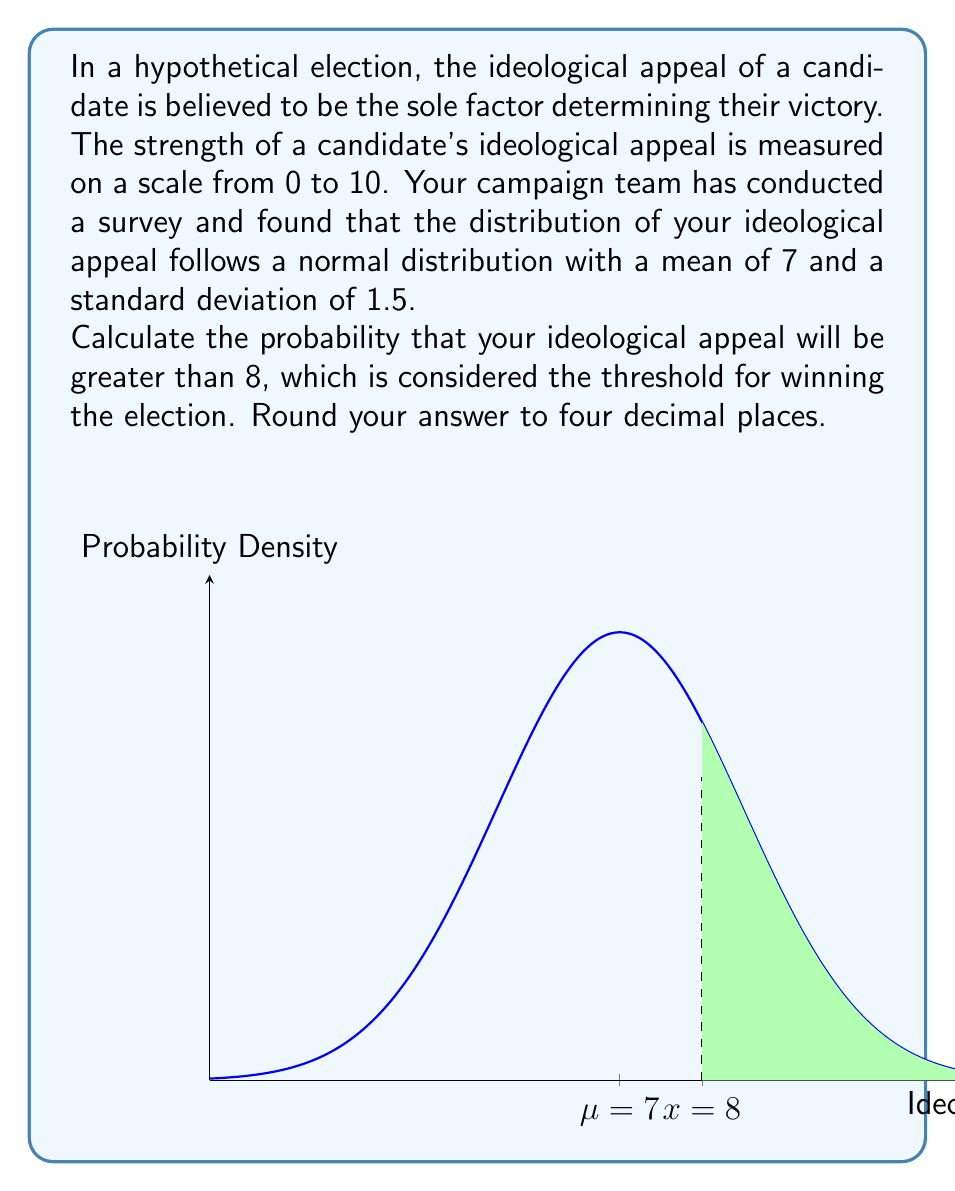Could you help me with this problem? To solve this problem, we need to use the properties of the normal distribution and the concept of z-scores. Here's a step-by-step approach:

1) We are given that the ideological appeal follows a normal distribution with:
   Mean (μ) = 7
   Standard deviation (σ) = 1.5

2) We want to find P(X > 8), where X is the ideological appeal.

3) To standardize this, we calculate the z-score for X = 8:

   $$ z = \frac{X - μ}{σ} = \frac{8 - 7}{1.5} = \frac{1}{1.5} ≈ 0.6667 $$

4) Now, we need to find P(Z > 0.6667), where Z is the standard normal variable.

5) Using a standard normal table or calculator, we can find that:
   P(Z < 0.6667) ≈ 0.7476

6) Since we want P(Z > 0.6667), we subtract this from 1:

   P(Z > 0.6667) = 1 - P(Z < 0.6667) = 1 - 0.7476 = 0.2524

7) Rounding to four decimal places, we get 0.2524.

Therefore, the probability that your ideological appeal will be greater than 8, thus winning the election, is approximately 0.2524 or 25.24%.
Answer: 0.2524 